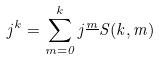<formula> <loc_0><loc_0><loc_500><loc_500>j ^ { k } = \sum _ { m = 0 } ^ { k } j ^ { \underline { m } } S ( k , m )</formula> 